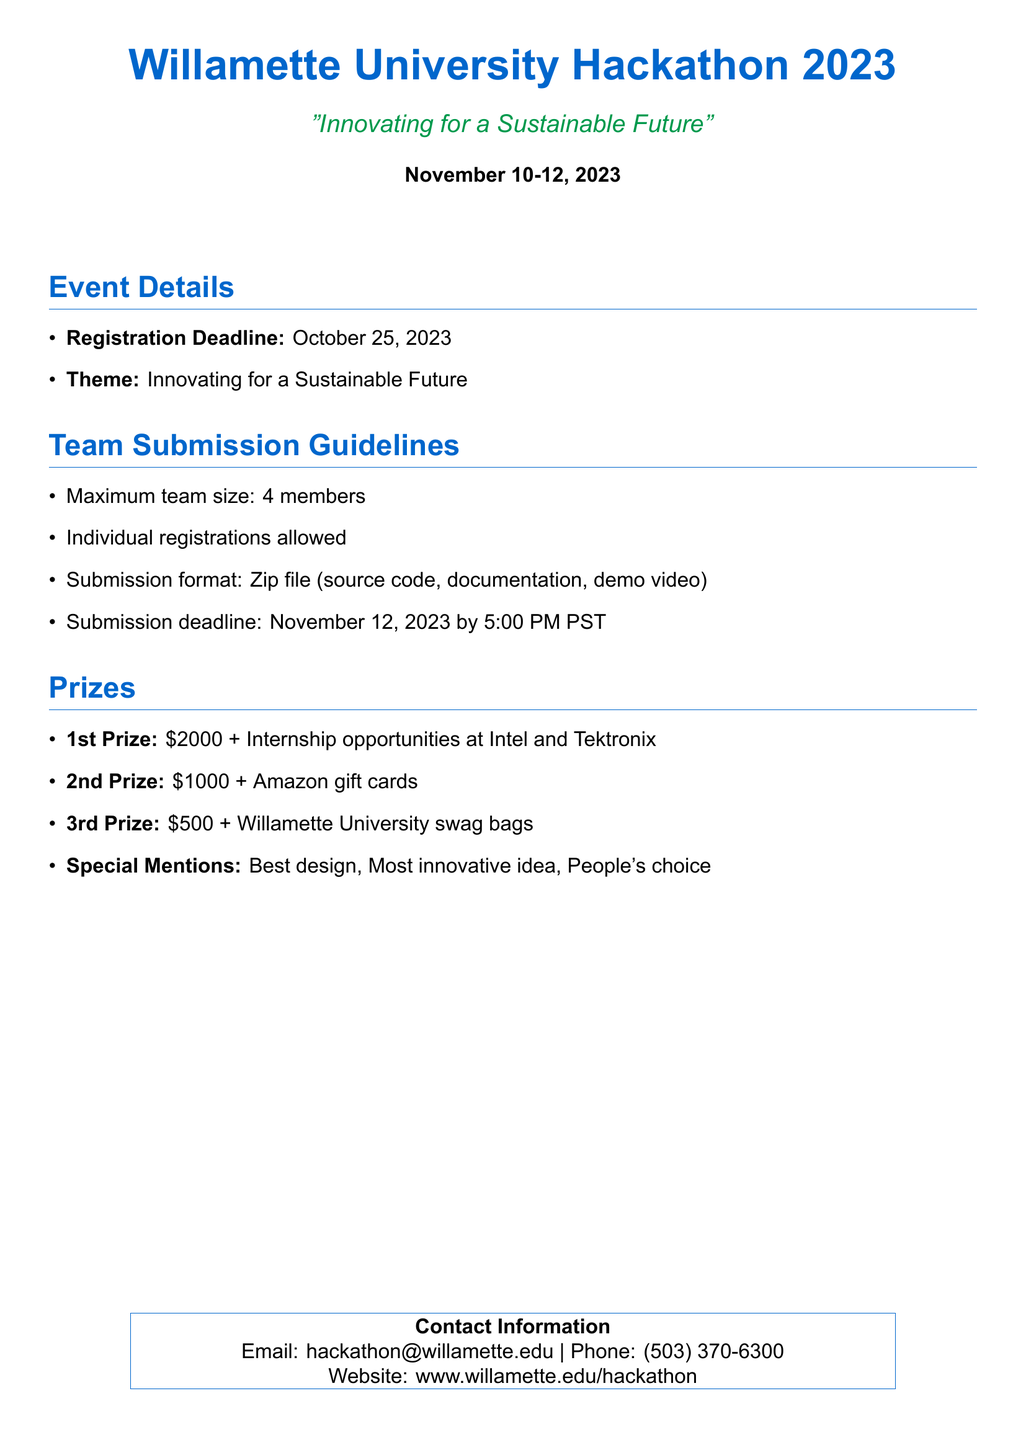What is the theme of the hackathon? The theme is explicitly stated in the document as the main focus of the event.
Answer: Innovating for a Sustainable Future What are the dates of the hackathon? The dates are mentioned prominently at the beginning of the document.
Answer: November 10-12, 2023 When is the registration deadline? The registration deadline is clearly indicated in the event details.
Answer: October 25, 2023 What is the maximum team size for the hackathon? This information is provided in the team submission guidelines section.
Answer: 4 members What format is required for submission? The document specifies the expected format for submissions in the guidelines section.
Answer: Zip file What is the prize for the first place? The prizes are listed in the document, including the top prize.
Answer: $2000 + Internship opportunities at Intel and Tektronix When is the submission deadline for projects? The submission deadline is given along with submission details in the document.
Answer: November 12, 2023 by 5:00 PM PST What is the email contact for the event? The contact information section specifies the email address for inquiries.
Answer: hackathon@willamette.edu What is offered for the second prize? The prize details section outlines what is included with the second prize.
Answer: $1000 + Amazon gift cards 